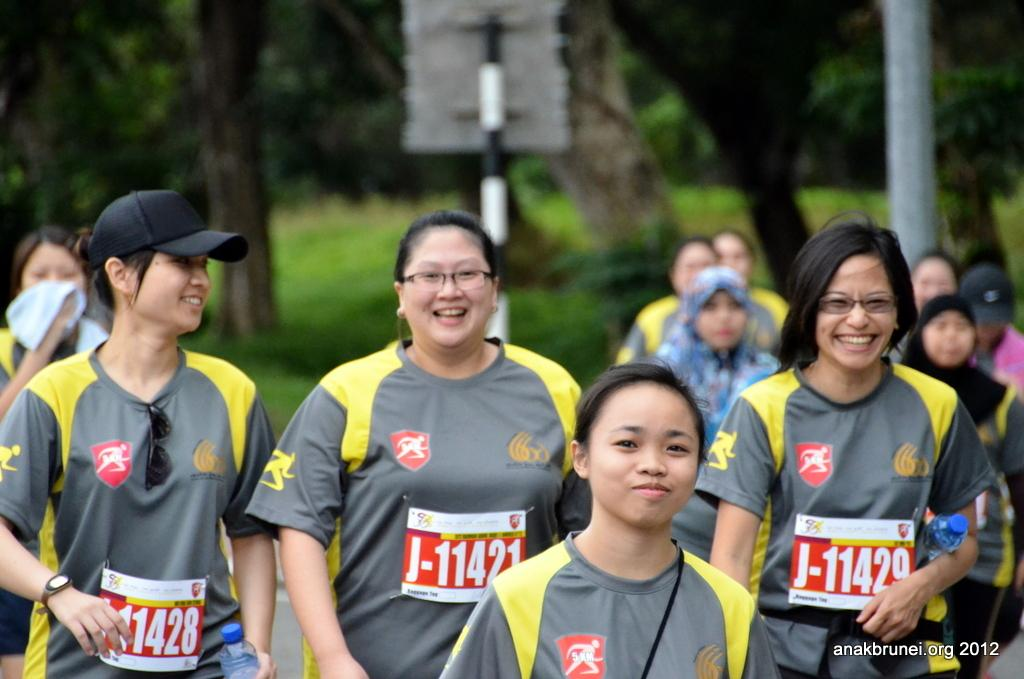What are the people in the image doing? The people in the image are walking. What can be seen in the background of the image? There are trees and poles in the background of the image. How is the background of the image depicted? The background is blurred. Is there any text present in the image? Yes, there is text in the bottom right corner of the image. What type of bucket is holding in the image? There is no bucket present in the image; it features people walking with a blurred background and text in the bottom right corner. Can you tell me the user's account balance from the image? There is no information about the user's account balance in the image. 